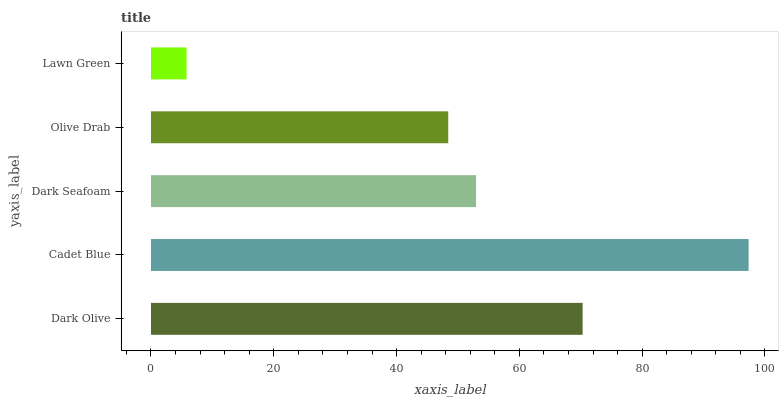Is Lawn Green the minimum?
Answer yes or no. Yes. Is Cadet Blue the maximum?
Answer yes or no. Yes. Is Dark Seafoam the minimum?
Answer yes or no. No. Is Dark Seafoam the maximum?
Answer yes or no. No. Is Cadet Blue greater than Dark Seafoam?
Answer yes or no. Yes. Is Dark Seafoam less than Cadet Blue?
Answer yes or no. Yes. Is Dark Seafoam greater than Cadet Blue?
Answer yes or no. No. Is Cadet Blue less than Dark Seafoam?
Answer yes or no. No. Is Dark Seafoam the high median?
Answer yes or no. Yes. Is Dark Seafoam the low median?
Answer yes or no. Yes. Is Lawn Green the high median?
Answer yes or no. No. Is Cadet Blue the low median?
Answer yes or no. No. 